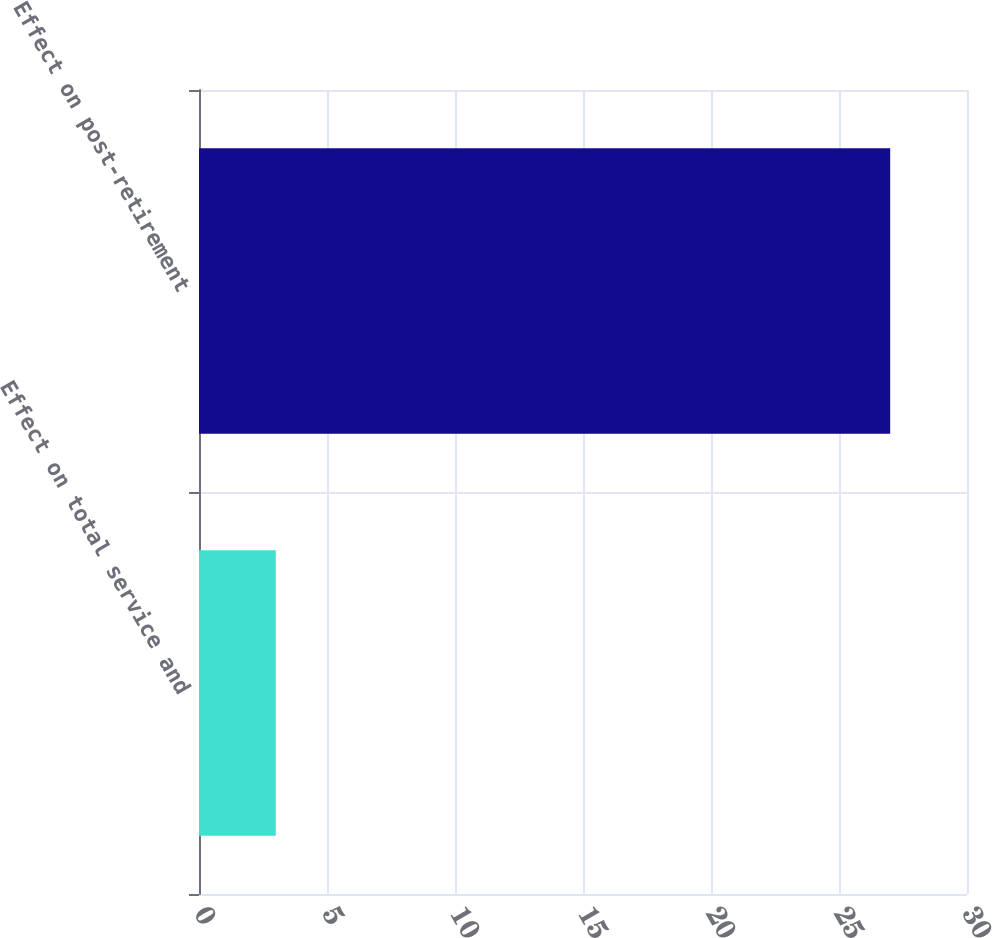<chart> <loc_0><loc_0><loc_500><loc_500><bar_chart><fcel>Effect on total service and<fcel>Effect on post-retirement<nl><fcel>3<fcel>27<nl></chart> 